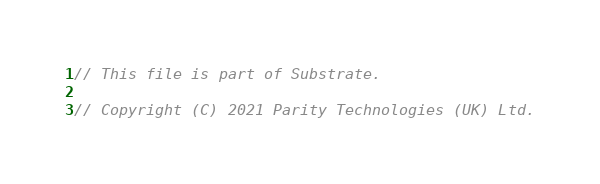<code> <loc_0><loc_0><loc_500><loc_500><_Rust_>// This file is part of Substrate.

// Copyright (C) 2021 Parity Technologies (UK) Ltd.</code> 